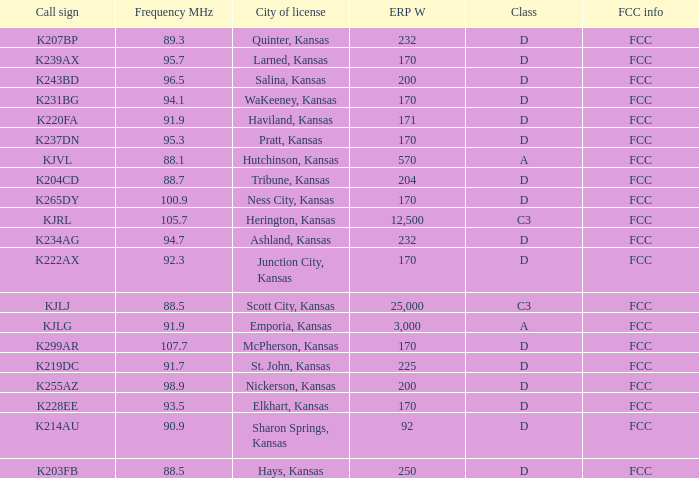Class of d, and a Frequency MHz smaller than 107.7, and a ERP W smaller than 232 has what call sign? K255AZ, K228EE, K220FA, K265DY, K237DN, K214AU, K222AX, K239AX, K243BD, K219DC, K204CD, K231BG. 